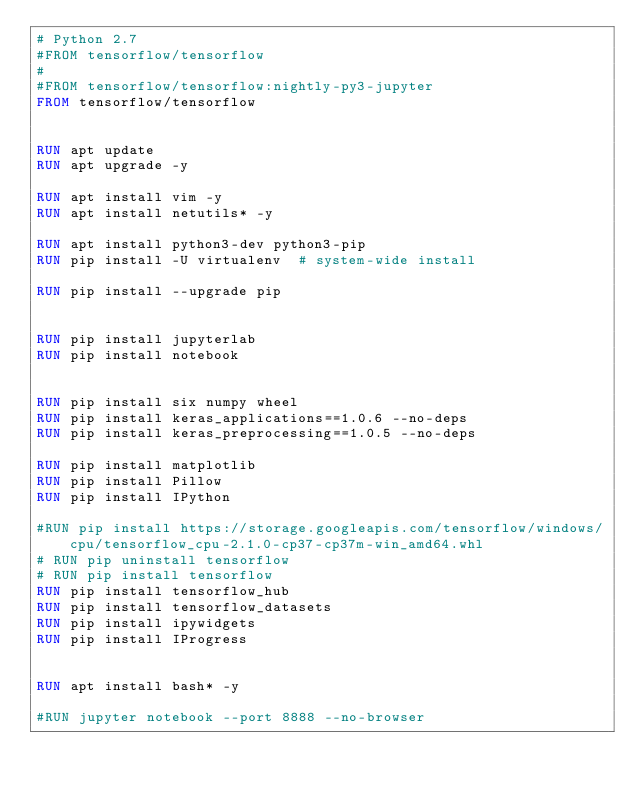<code> <loc_0><loc_0><loc_500><loc_500><_Dockerfile_># Python 2.7
#FROM tensorflow/tensorflow 
# 
#FROM tensorflow/tensorflow:nightly-py3-jupyter
FROM tensorflow/tensorflow


RUN apt update
RUN apt upgrade -y

RUN apt install vim -y
RUN apt install netutils* -y

RUN apt install python3-dev python3-pip
RUN pip install -U virtualenv  # system-wide install

RUN pip install --upgrade pip


RUN pip install jupyterlab
RUN pip install notebook


RUN pip install six numpy wheel
RUN pip install keras_applications==1.0.6 --no-deps
RUN pip install keras_preprocessing==1.0.5 --no-deps

RUN pip install matplotlib
RUN pip install Pillow
RUN pip install IPython

#RUN pip install https://storage.googleapis.com/tensorflow/windows/cpu/tensorflow_cpu-2.1.0-cp37-cp37m-win_amd64.whl
# RUN pip uninstall tensorflow
# RUN pip install tensorflow
RUN pip install tensorflow_hub
RUN pip install tensorflow_datasets
RUN pip install ipywidgets
RUN pip install IProgress


RUN apt install bash* -y

#RUN jupyter notebook --port 8888 --no-browser
</code> 